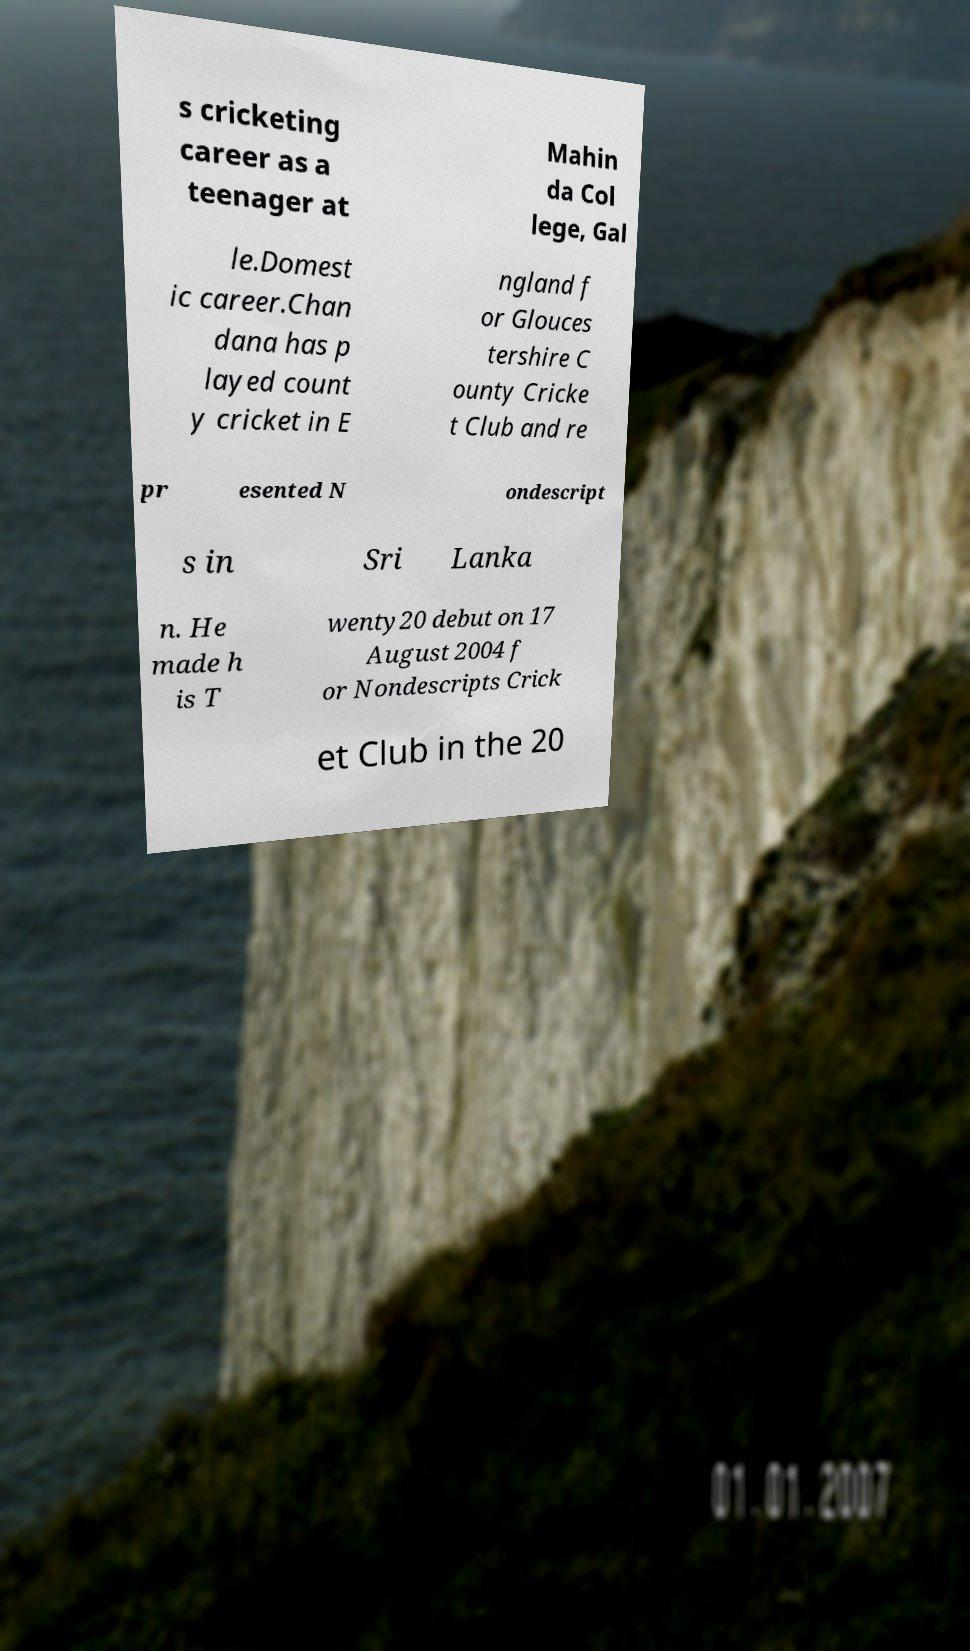Please identify and transcribe the text found in this image. s cricketing career as a teenager at Mahin da Col lege, Gal le.Domest ic career.Chan dana has p layed count y cricket in E ngland f or Glouces tershire C ounty Cricke t Club and re pr esented N ondescript s in Sri Lanka n. He made h is T wenty20 debut on 17 August 2004 f or Nondescripts Crick et Club in the 20 